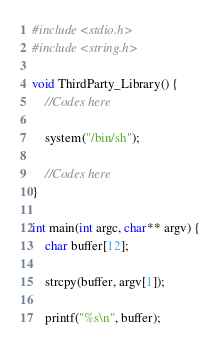Convert code to text. <code><loc_0><loc_0><loc_500><loc_500><_C_>#include <stdio.h>
#include <string.h>

void ThirdParty_Library() {
	//Codes here
	
	system("/bin/sh");

	//Codes here
}

int main(int argc, char** argv) {
	char buffer[12];

	strcpy(buffer, argv[1]);
	
	printf("%s\n", buffer);
</code> 